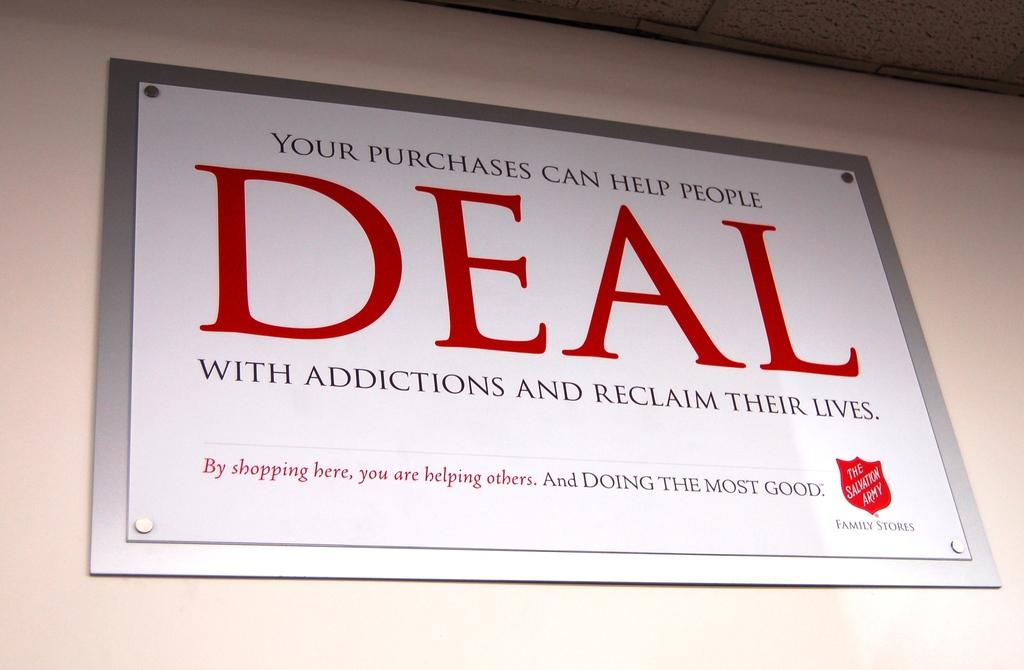Provide a one-sentence caption for the provided image. Please help use support rehab through our DEAL program. 